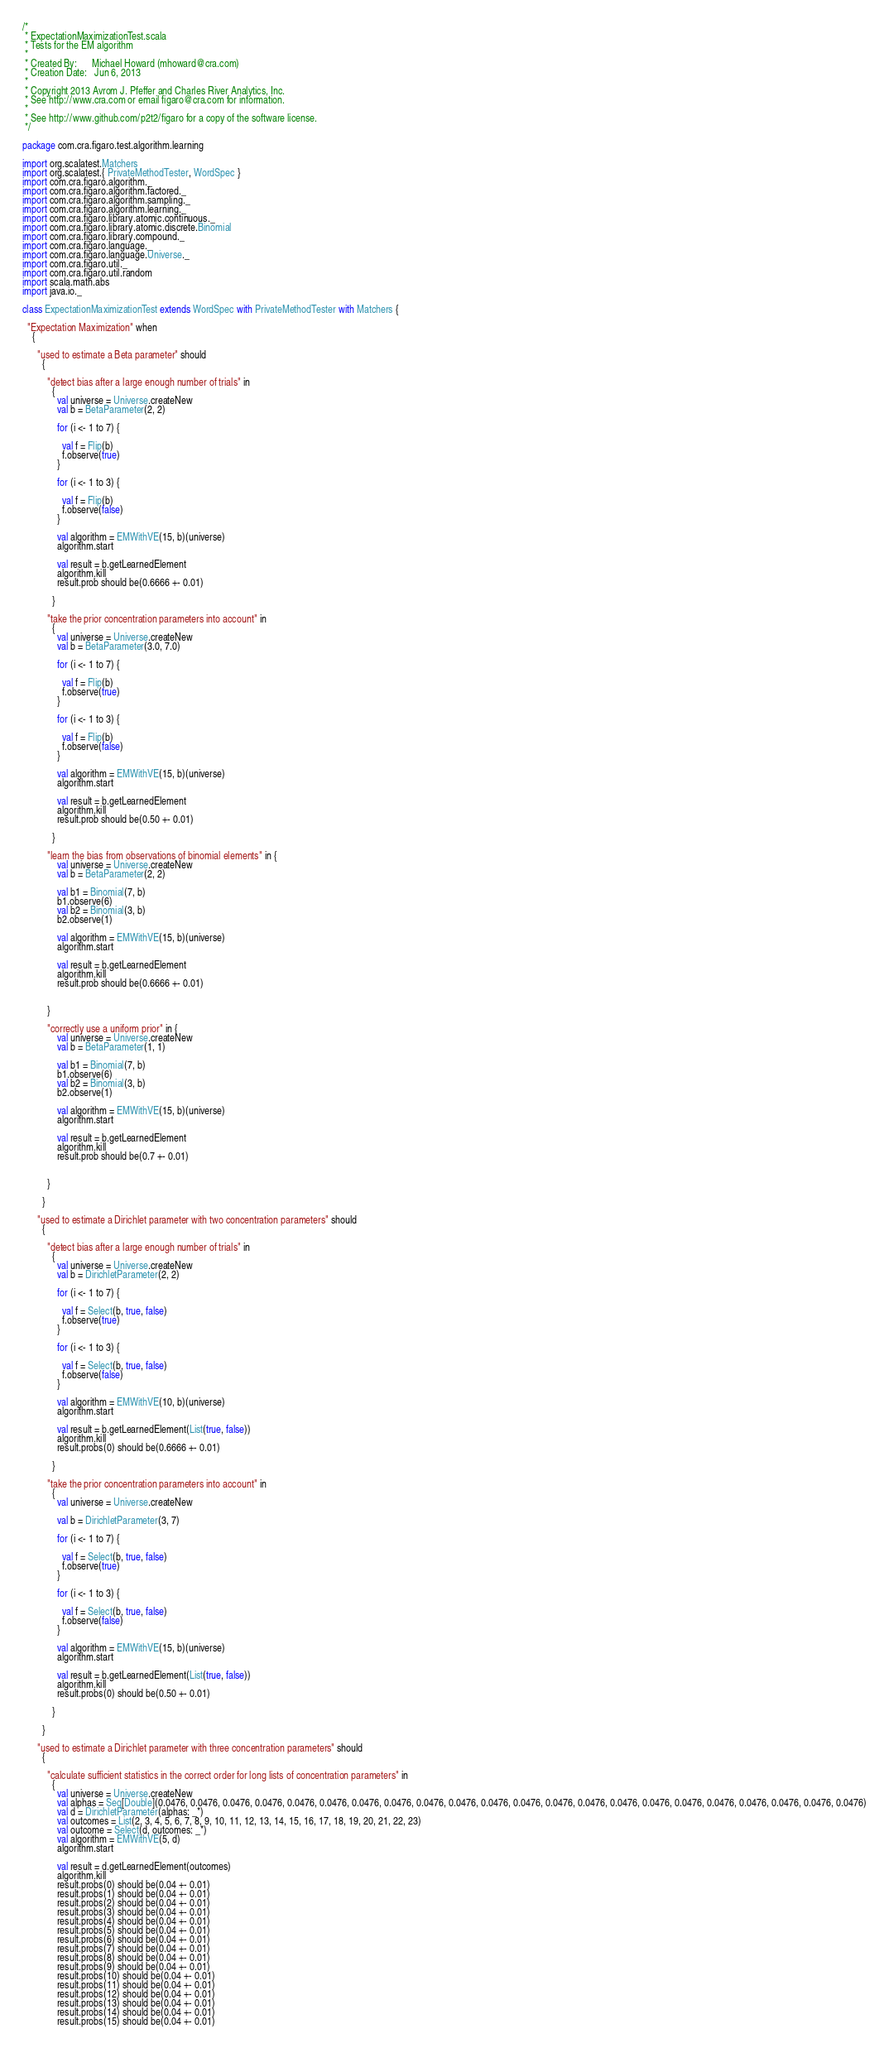Convert code to text. <code><loc_0><loc_0><loc_500><loc_500><_Scala_>/*
 * ExpectationMaximizationTest.scala
 * Tests for the EM algorithm
 * 
 * Created By:      Michael Howard (mhoward@cra.com)
 * Creation Date:   Jun 6, 2013
 * 
 * Copyright 2013 Avrom J. Pfeffer and Charles River Analytics, Inc.
 * See http://www.cra.com or email figaro@cra.com for information.
 * 
 * See http://www.github.com/p2t2/figaro for a copy of the software license.
 */

package com.cra.figaro.test.algorithm.learning

import org.scalatest.Matchers
import org.scalatest.{ PrivateMethodTester, WordSpec }
import com.cra.figaro.algorithm._
import com.cra.figaro.algorithm.factored._
import com.cra.figaro.algorithm.sampling._
import com.cra.figaro.algorithm.learning._
import com.cra.figaro.library.atomic.continuous._
import com.cra.figaro.library.atomic.discrete.Binomial
import com.cra.figaro.library.compound._
import com.cra.figaro.language._
import com.cra.figaro.language.Universe._
import com.cra.figaro.util._
import com.cra.figaro.util.random
import scala.math.abs
import java.io._

class ExpectationMaximizationTest extends WordSpec with PrivateMethodTester with Matchers {

  "Expectation Maximization" when
    {

      "used to estimate a Beta parameter" should
        {

          "detect bias after a large enough number of trials" in
            {
              val universe = Universe.createNew
              val b = BetaParameter(2, 2)

              for (i <- 1 to 7) {

                val f = Flip(b)
                f.observe(true)
              }

              for (i <- 1 to 3) {

                val f = Flip(b)
                f.observe(false)
              }

              val algorithm = EMWithVE(15, b)(universe)
              algorithm.start

              val result = b.getLearnedElement
              algorithm.kill
              result.prob should be(0.6666 +- 0.01)

            }

          "take the prior concentration parameters into account" in
            {
              val universe = Universe.createNew
              val b = BetaParameter(3.0, 7.0)

              for (i <- 1 to 7) {

                val f = Flip(b)
                f.observe(true)
              }

              for (i <- 1 to 3) {

                val f = Flip(b)
                f.observe(false)
              }
              
              val algorithm = EMWithVE(15, b)(universe)
              algorithm.start

              val result = b.getLearnedElement
              algorithm.kill
              result.prob should be(0.50 +- 0.01)

            }

          "learn the bias from observations of binomial elements" in {
              val universe = Universe.createNew
              val b = BetaParameter(2, 2)

              val b1 = Binomial(7, b)
              b1.observe(6)
              val b2 = Binomial(3, b)
              b2.observe(1)

              val algorithm = EMWithVE(15, b)(universe)
              algorithm.start

              val result = b.getLearnedElement
              algorithm.kill
              result.prob should be(0.6666 +- 0.01)
  

          }

          "correctly use a uniform prior" in {
              val universe = Universe.createNew
              val b = BetaParameter(1, 1)

              val b1 = Binomial(7, b)
              b1.observe(6)
              val b2 = Binomial(3, b)
              b2.observe(1)

              val algorithm = EMWithVE(15, b)(universe)
              algorithm.start

              val result = b.getLearnedElement
              algorithm.kill
              result.prob should be(0.7 +- 0.01)

            
          }

        }

      "used to estimate a Dirichlet parameter with two concentration parameters" should
        {

          "detect bias after a large enough number of trials" in
            {
              val universe = Universe.createNew
              val b = DirichletParameter(2, 2)

              for (i <- 1 to 7) {

                val f = Select(b, true, false)
                f.observe(true)
              }

              for (i <- 1 to 3) {

                val f = Select(b, true, false)
                f.observe(false)
              }

              val algorithm = EMWithVE(10, b)(universe)
              algorithm.start

              val result = b.getLearnedElement(List(true, false))
              algorithm.kill
              result.probs(0) should be(0.6666 +- 0.01)

            }

          "take the prior concentration parameters into account" in
            {
              val universe = Universe.createNew

              val b = DirichletParameter(3, 7)

              for (i <- 1 to 7) {

                val f = Select(b, true, false)
                f.observe(true)
              }

              for (i <- 1 to 3) {

                val f = Select(b, true, false)
                f.observe(false)
              }

              val algorithm = EMWithVE(15, b)(universe)
              algorithm.start

              val result = b.getLearnedElement(List(true, false))
              algorithm.kill
              result.probs(0) should be(0.50 +- 0.01)

            }

        }

      "used to estimate a Dirichlet parameter with three concentration parameters" should
        {

          "calculate sufficient statistics in the correct order for long lists of concentration parameters" in
            {
              val universe = Universe.createNew
              val alphas = Seq[Double](0.0476, 0.0476, 0.0476, 0.0476, 0.0476, 0.0476, 0.0476, 0.0476, 0.0476, 0.0476, 0.0476, 0.0476, 0.0476, 0.0476, 0.0476, 0.0476, 0.0476, 0.0476, 0.0476, 0.0476, 0.0476, 0.0476)
              val d = DirichletParameter(alphas: _*)
              val outcomes = List(2, 3, 4, 5, 6, 7, 8, 9, 10, 11, 12, 13, 14, 15, 16, 17, 18, 19, 20, 21, 22, 23)
              val outcome = Select(d, outcomes: _*)
              val algorithm = EMWithVE(5, d)
              algorithm.start

              val result = d.getLearnedElement(outcomes)
              algorithm.kill
              result.probs(0) should be(0.04 +- 0.01)
              result.probs(1) should be(0.04 +- 0.01)
              result.probs(2) should be(0.04 +- 0.01)
              result.probs(3) should be(0.04 +- 0.01)
              result.probs(4) should be(0.04 +- 0.01)
              result.probs(5) should be(0.04 +- 0.01)
              result.probs(6) should be(0.04 +- 0.01)
              result.probs(7) should be(0.04 +- 0.01)
              result.probs(8) should be(0.04 +- 0.01)
              result.probs(9) should be(0.04 +- 0.01)
              result.probs(10) should be(0.04 +- 0.01)
              result.probs(11) should be(0.04 +- 0.01)
              result.probs(12) should be(0.04 +- 0.01)
              result.probs(13) should be(0.04 +- 0.01)
              result.probs(14) should be(0.04 +- 0.01)
              result.probs(15) should be(0.04 +- 0.01)</code> 